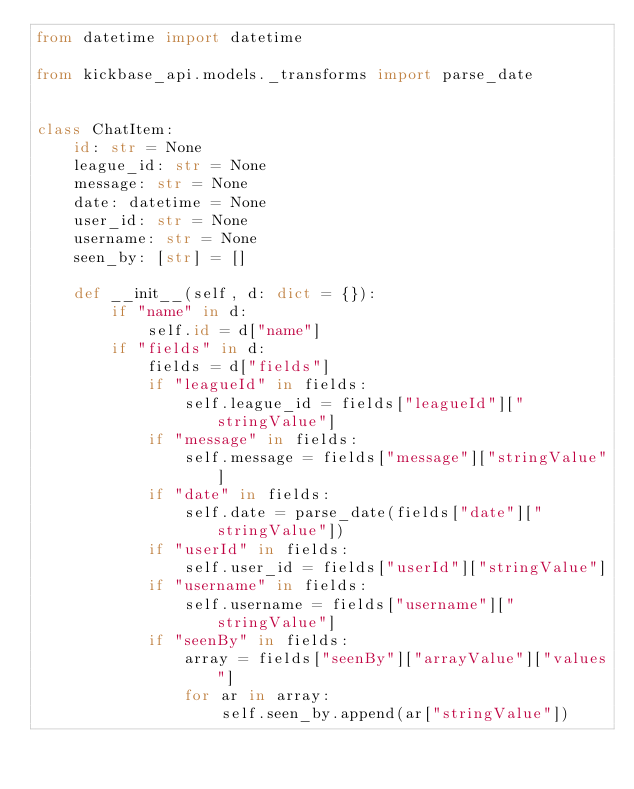Convert code to text. <code><loc_0><loc_0><loc_500><loc_500><_Python_>from datetime import datetime

from kickbase_api.models._transforms import parse_date


class ChatItem:
    id: str = None
    league_id: str = None
    message: str = None
    date: datetime = None
    user_id: str = None
    username: str = None
    seen_by: [str] = []

    def __init__(self, d: dict = {}):
        if "name" in d:
            self.id = d["name"]
        if "fields" in d:
            fields = d["fields"]
            if "leagueId" in fields:
                self.league_id = fields["leagueId"]["stringValue"]
            if "message" in fields:
                self.message = fields["message"]["stringValue"]
            if "date" in fields:
                self.date = parse_date(fields["date"]["stringValue"])
            if "userId" in fields:
                self.user_id = fields["userId"]["stringValue"]
            if "username" in fields:
                self.username = fields["username"]["stringValue"]
            if "seenBy" in fields:
                array = fields["seenBy"]["arrayValue"]["values"]
                for ar in array:
                    self.seen_by.append(ar["stringValue"])
</code> 